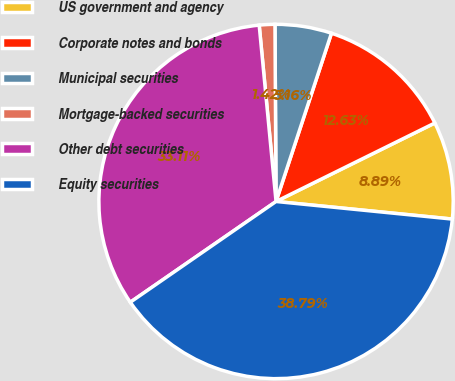Convert chart to OTSL. <chart><loc_0><loc_0><loc_500><loc_500><pie_chart><fcel>US government and agency<fcel>Corporate notes and bonds<fcel>Municipal securities<fcel>Mortgage-backed securities<fcel>Other debt securities<fcel>Equity securities<nl><fcel>8.89%<fcel>12.63%<fcel>5.16%<fcel>1.42%<fcel>33.11%<fcel>38.79%<nl></chart> 